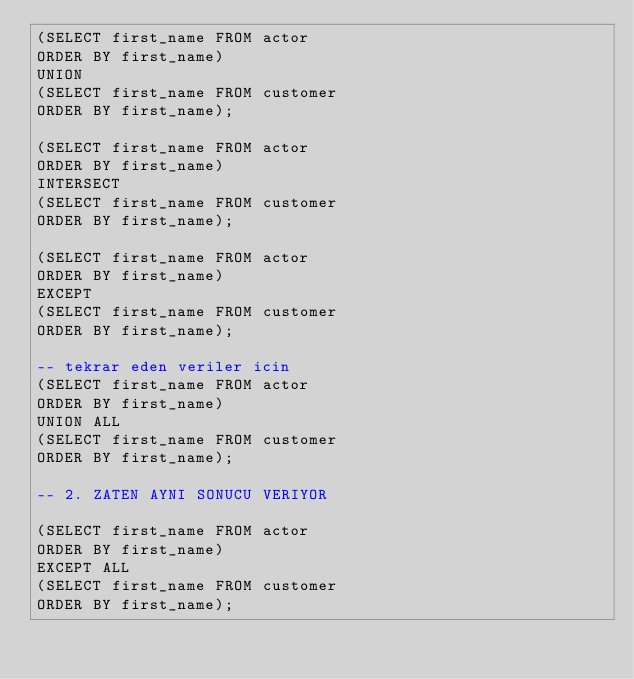Convert code to text. <code><loc_0><loc_0><loc_500><loc_500><_SQL_>(SELECT first_name FROM actor 
ORDER BY first_name)
UNION 
(SELECT first_name FROM customer 
ORDER BY first_name);

(SELECT first_name FROM actor
ORDER BY first_name)
INTERSECT 
(SELECT first_name FROM customer
ORDER BY first_name);

(SELECT first_name FROM actor 
ORDER BY first_name)
EXCEPT
(SELECT first_name FROM customer 
ORDER BY first_name);

-- tekrar eden veriler icin
(SELECT first_name FROM actor 
ORDER BY first_name)
UNION ALL
(SELECT first_name FROM customer 
ORDER BY first_name);

-- 2. ZATEN AYNI SONUCU VERIYOR

(SELECT first_name FROM actor 
ORDER BY first_name)
EXCEPT ALL
(SELECT first_name FROM customer 
ORDER BY first_name);
</code> 